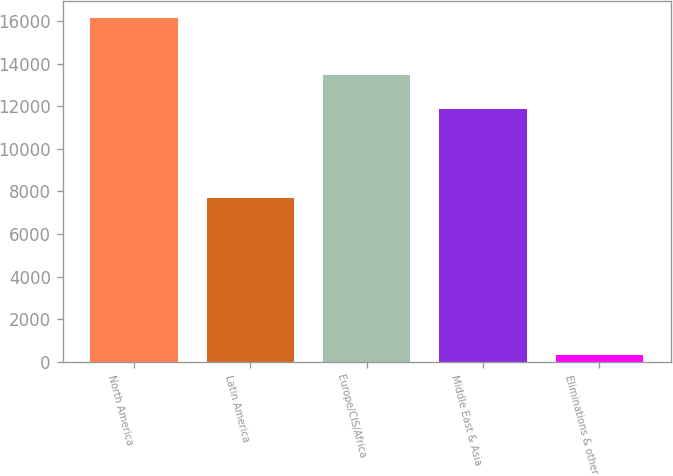Convert chart. <chart><loc_0><loc_0><loc_500><loc_500><bar_chart><fcel>North America<fcel>Latin America<fcel>Europe/CIS/Africa<fcel>Middle East & Asia<fcel>Eliminations & other<nl><fcel>16151<fcel>7699<fcel>13456.1<fcel>11875<fcel>340<nl></chart> 